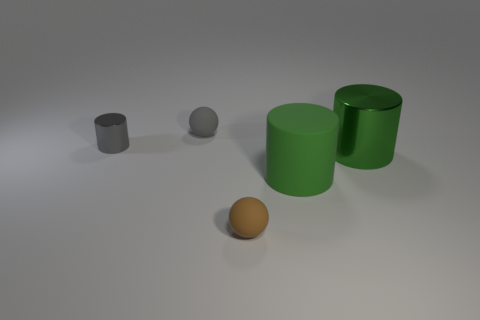Add 3 small brown spheres. How many objects exist? 8 Subtract all balls. How many objects are left? 3 Subtract all small metal cylinders. Subtract all large metallic cylinders. How many objects are left? 3 Add 2 large cylinders. How many large cylinders are left? 4 Add 5 gray balls. How many gray balls exist? 6 Subtract 0 brown blocks. How many objects are left? 5 